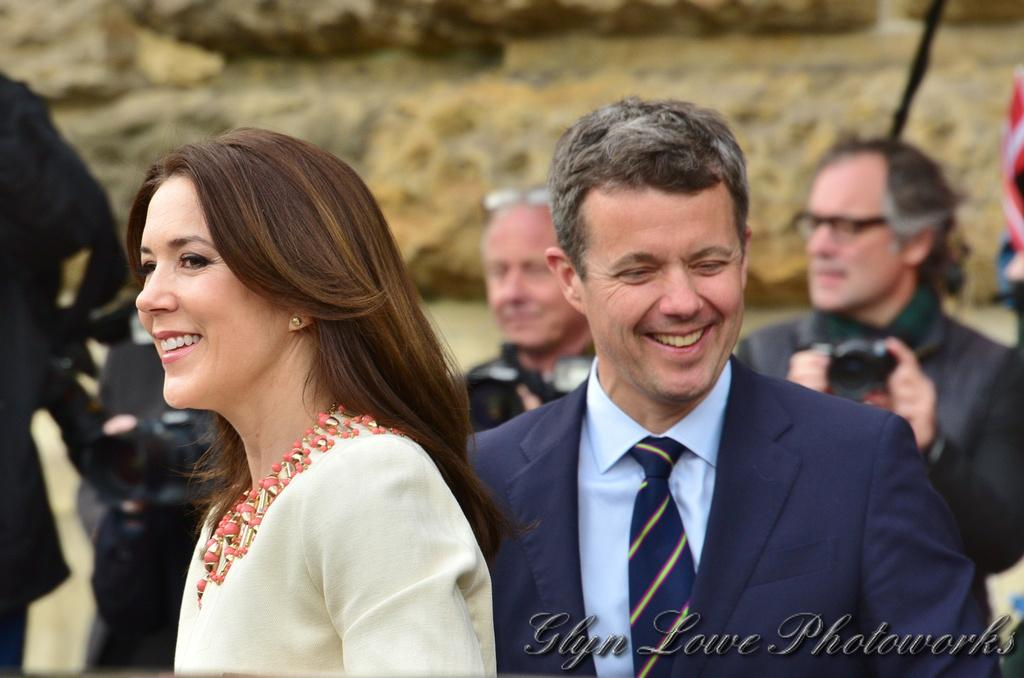What are the people in the image doing? The man and woman in the image are standing and smiling. How many people are in the image? There are people standing in the image, but the exact number is not specified. What can be observed about the background of the image? The background of the image appears blurry. Is there any additional information or marking on the image? Yes, there is a watermark on the image. What type of shoe is the cat wearing in the image? There is no cat or shoe present in the image. 